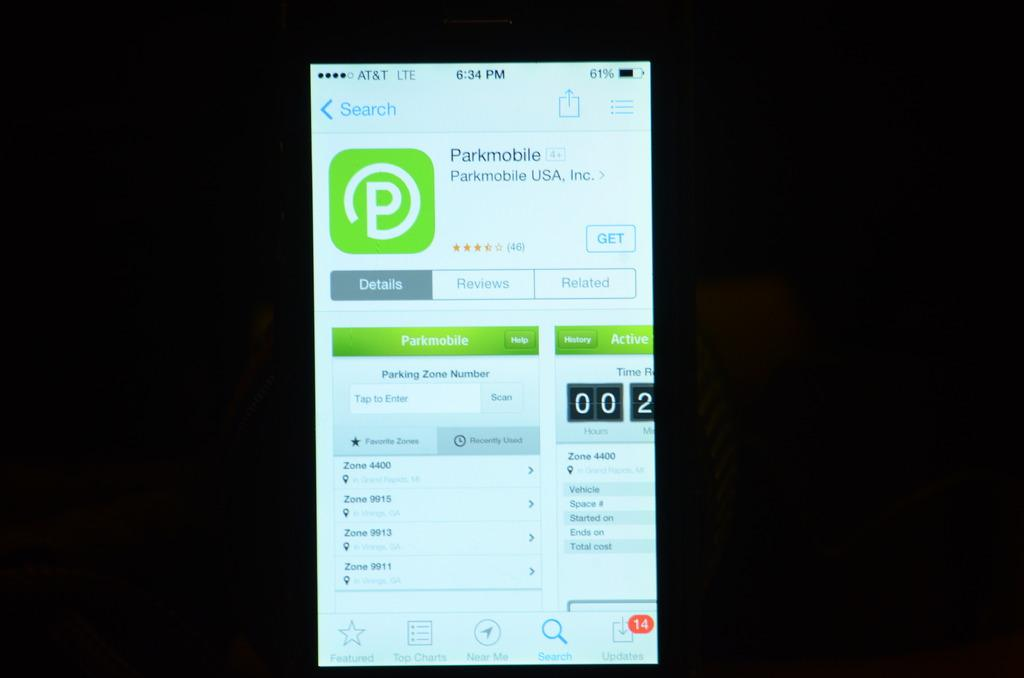<image>
Summarize the visual content of the image. a screen of a cellphone with Parkmobile carrier 